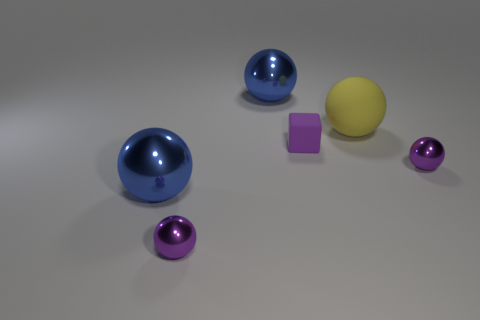Add 2 blue metal objects. How many objects exist? 8 Subtract all big blue metal balls. How many balls are left? 3 Subtract all spheres. How many objects are left? 1 Subtract all tiny gray matte things. Subtract all small purple matte things. How many objects are left? 5 Add 4 matte objects. How many matte objects are left? 6 Add 4 small purple balls. How many small purple balls exist? 6 Subtract all yellow spheres. How many spheres are left? 4 Subtract 0 blue blocks. How many objects are left? 6 Subtract 1 blocks. How many blocks are left? 0 Subtract all red cubes. Subtract all purple cylinders. How many cubes are left? 1 